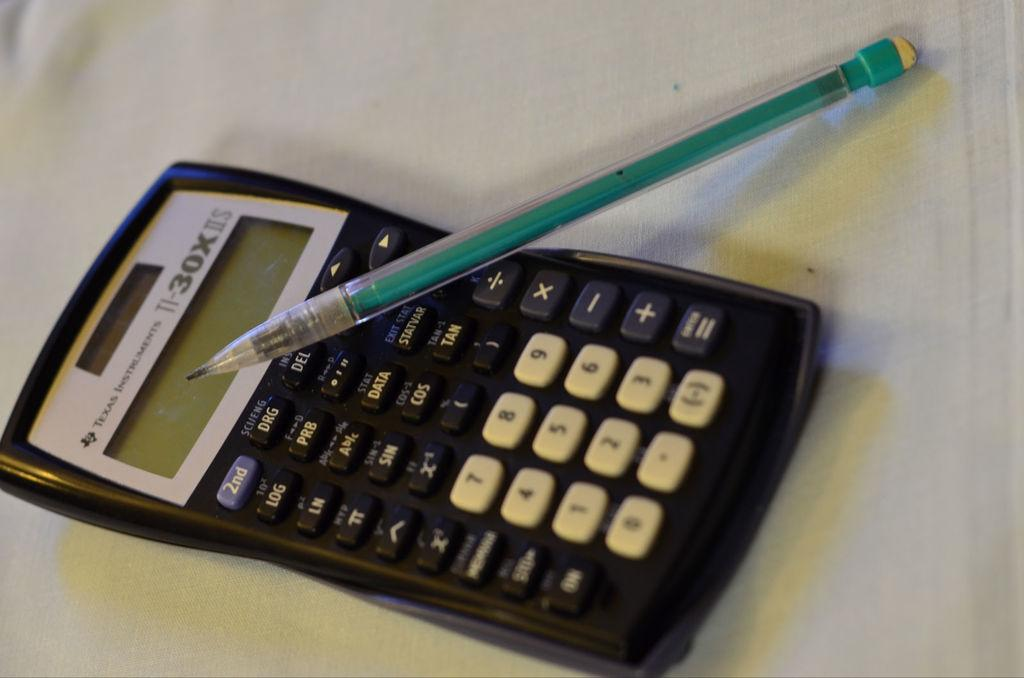<image>
Summarize the visual content of the image. A Texas Instruments style T1 30X ii style hand held calculator with a teal colored pencil leaning on it. 